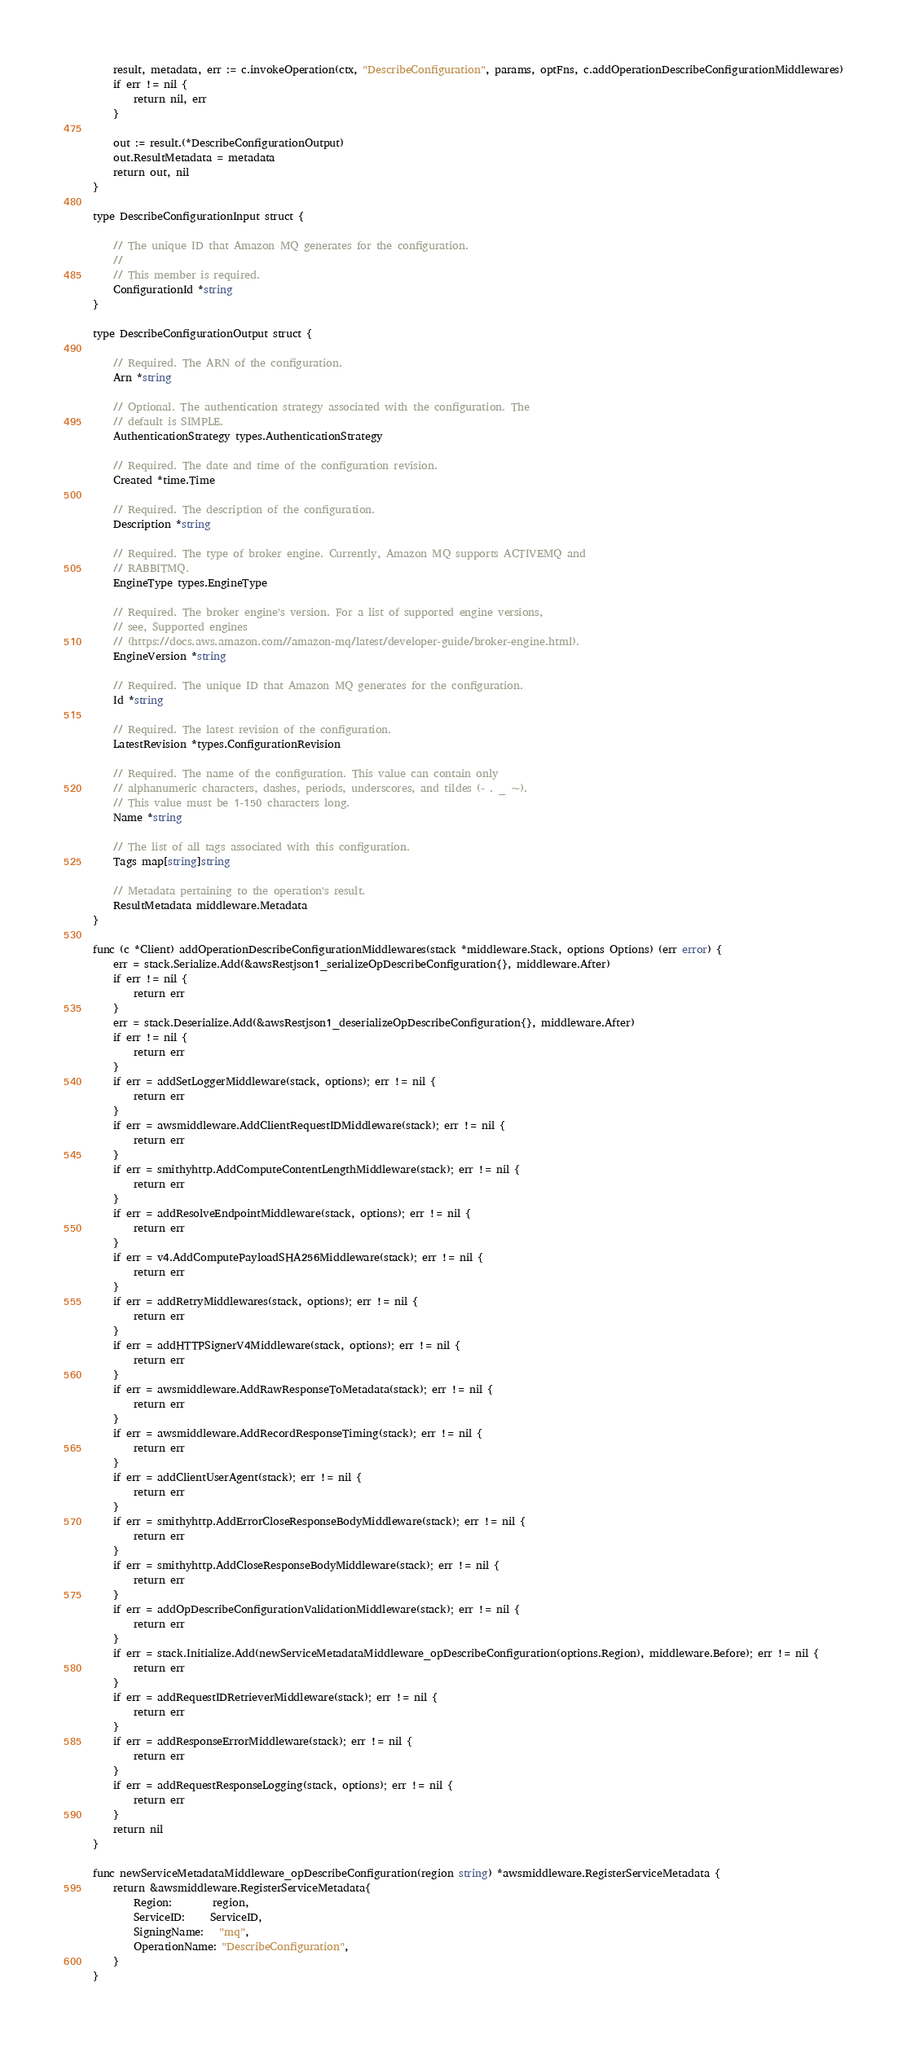<code> <loc_0><loc_0><loc_500><loc_500><_Go_>
	result, metadata, err := c.invokeOperation(ctx, "DescribeConfiguration", params, optFns, c.addOperationDescribeConfigurationMiddlewares)
	if err != nil {
		return nil, err
	}

	out := result.(*DescribeConfigurationOutput)
	out.ResultMetadata = metadata
	return out, nil
}

type DescribeConfigurationInput struct {

	// The unique ID that Amazon MQ generates for the configuration.
	//
	// This member is required.
	ConfigurationId *string
}

type DescribeConfigurationOutput struct {

	// Required. The ARN of the configuration.
	Arn *string

	// Optional. The authentication strategy associated with the configuration. The
	// default is SIMPLE.
	AuthenticationStrategy types.AuthenticationStrategy

	// Required. The date and time of the configuration revision.
	Created *time.Time

	// Required. The description of the configuration.
	Description *string

	// Required. The type of broker engine. Currently, Amazon MQ supports ACTIVEMQ and
	// RABBITMQ.
	EngineType types.EngineType

	// Required. The broker engine's version. For a list of supported engine versions,
	// see, Supported engines
	// (https://docs.aws.amazon.com//amazon-mq/latest/developer-guide/broker-engine.html).
	EngineVersion *string

	// Required. The unique ID that Amazon MQ generates for the configuration.
	Id *string

	// Required. The latest revision of the configuration.
	LatestRevision *types.ConfigurationRevision

	// Required. The name of the configuration. This value can contain only
	// alphanumeric characters, dashes, periods, underscores, and tildes (- . _ ~).
	// This value must be 1-150 characters long.
	Name *string

	// The list of all tags associated with this configuration.
	Tags map[string]string

	// Metadata pertaining to the operation's result.
	ResultMetadata middleware.Metadata
}

func (c *Client) addOperationDescribeConfigurationMiddlewares(stack *middleware.Stack, options Options) (err error) {
	err = stack.Serialize.Add(&awsRestjson1_serializeOpDescribeConfiguration{}, middleware.After)
	if err != nil {
		return err
	}
	err = stack.Deserialize.Add(&awsRestjson1_deserializeOpDescribeConfiguration{}, middleware.After)
	if err != nil {
		return err
	}
	if err = addSetLoggerMiddleware(stack, options); err != nil {
		return err
	}
	if err = awsmiddleware.AddClientRequestIDMiddleware(stack); err != nil {
		return err
	}
	if err = smithyhttp.AddComputeContentLengthMiddleware(stack); err != nil {
		return err
	}
	if err = addResolveEndpointMiddleware(stack, options); err != nil {
		return err
	}
	if err = v4.AddComputePayloadSHA256Middleware(stack); err != nil {
		return err
	}
	if err = addRetryMiddlewares(stack, options); err != nil {
		return err
	}
	if err = addHTTPSignerV4Middleware(stack, options); err != nil {
		return err
	}
	if err = awsmiddleware.AddRawResponseToMetadata(stack); err != nil {
		return err
	}
	if err = awsmiddleware.AddRecordResponseTiming(stack); err != nil {
		return err
	}
	if err = addClientUserAgent(stack); err != nil {
		return err
	}
	if err = smithyhttp.AddErrorCloseResponseBodyMiddleware(stack); err != nil {
		return err
	}
	if err = smithyhttp.AddCloseResponseBodyMiddleware(stack); err != nil {
		return err
	}
	if err = addOpDescribeConfigurationValidationMiddleware(stack); err != nil {
		return err
	}
	if err = stack.Initialize.Add(newServiceMetadataMiddleware_opDescribeConfiguration(options.Region), middleware.Before); err != nil {
		return err
	}
	if err = addRequestIDRetrieverMiddleware(stack); err != nil {
		return err
	}
	if err = addResponseErrorMiddleware(stack); err != nil {
		return err
	}
	if err = addRequestResponseLogging(stack, options); err != nil {
		return err
	}
	return nil
}

func newServiceMetadataMiddleware_opDescribeConfiguration(region string) *awsmiddleware.RegisterServiceMetadata {
	return &awsmiddleware.RegisterServiceMetadata{
		Region:        region,
		ServiceID:     ServiceID,
		SigningName:   "mq",
		OperationName: "DescribeConfiguration",
	}
}
</code> 